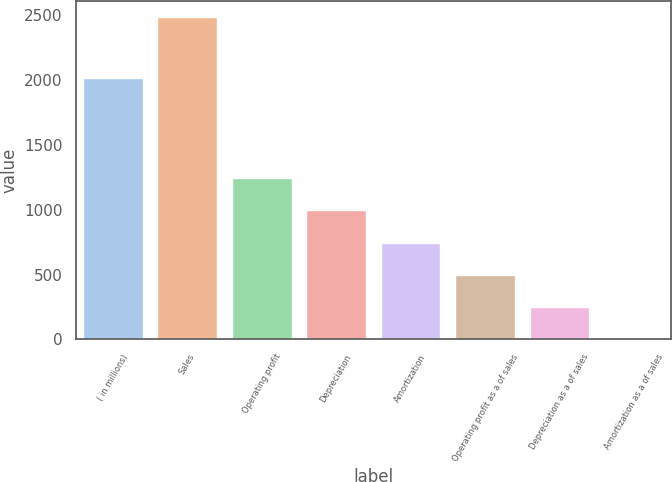Convert chart to OTSL. <chart><loc_0><loc_0><loc_500><loc_500><bar_chart><fcel>( in millions)<fcel>Sales<fcel>Operating profit<fcel>Depreciation<fcel>Amortization<fcel>Operating profit as a of sales<fcel>Depreciation as a of sales<fcel>Amortization as a of sales<nl><fcel>2016<fcel>2486.6<fcel>1243.75<fcel>995.18<fcel>746.61<fcel>498.04<fcel>249.47<fcel>0.9<nl></chart> 